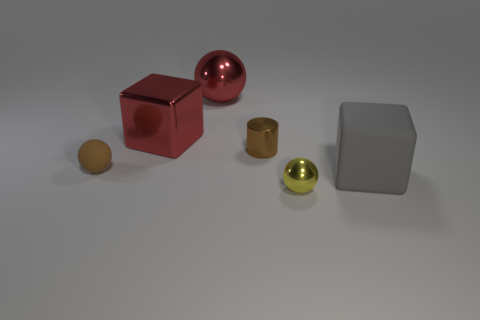Can you describe the texture and color of the ball closest to us in the image? The ball closest to the viewer has a matte texture, which diffuses light and gives it a non-reflective surface. Its color is a muted brown, similar to the color of clay or dry earth. 